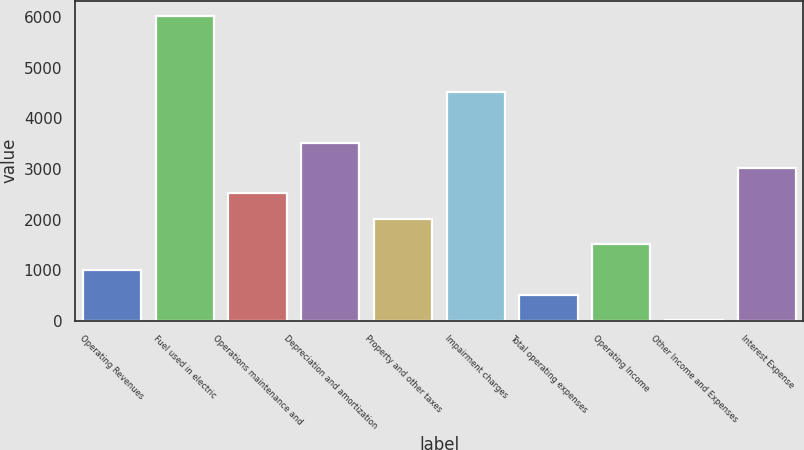<chart> <loc_0><loc_0><loc_500><loc_500><bar_chart><fcel>Operating Revenues<fcel>Fuel used in electric<fcel>Operations maintenance and<fcel>Depreciation and amortization<fcel>Property and other taxes<fcel>Impairment charges<fcel>Total operating expenses<fcel>Operating Income<fcel>Other Income and Expenses<fcel>Interest Expense<nl><fcel>1009.4<fcel>6031.4<fcel>2516<fcel>3520.4<fcel>2013.8<fcel>4524.8<fcel>507.2<fcel>1511.6<fcel>5<fcel>3018.2<nl></chart> 